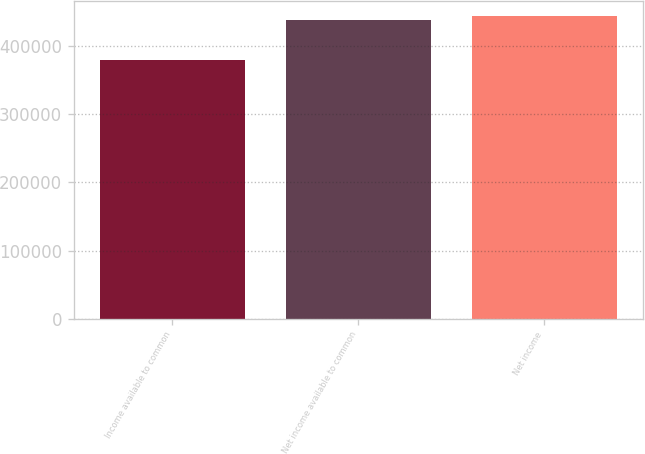Convert chart to OTSL. <chart><loc_0><loc_0><loc_500><loc_500><bar_chart><fcel>Income available to common<fcel>Net income available to common<fcel>Net income<nl><fcel>379532<fcel>438292<fcel>444168<nl></chart> 